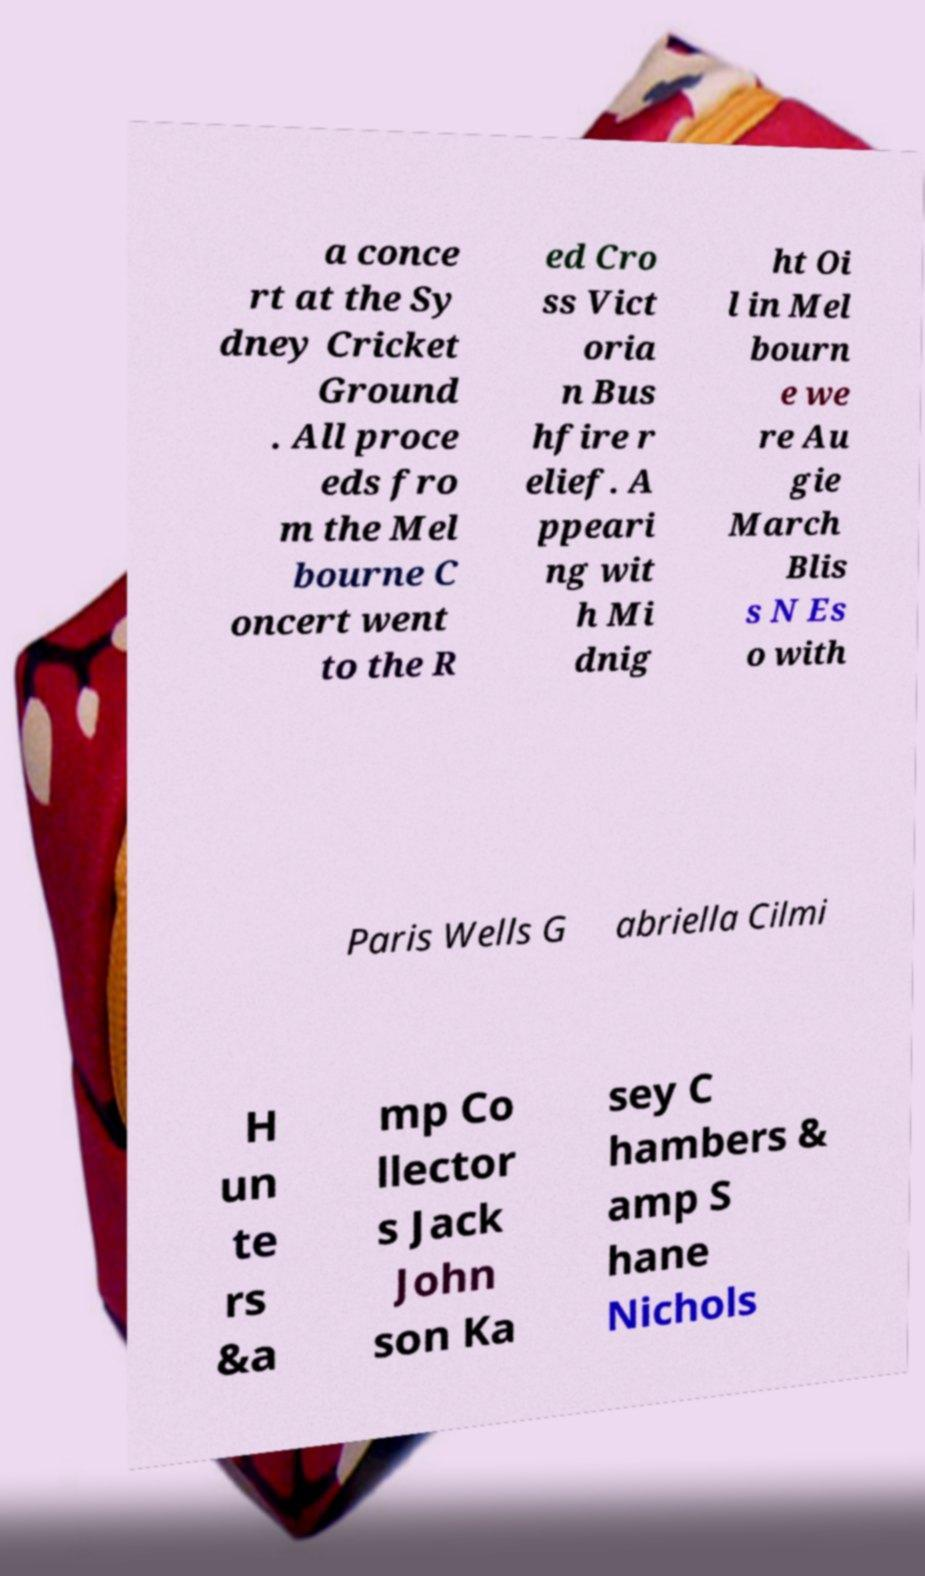Please identify and transcribe the text found in this image. a conce rt at the Sy dney Cricket Ground . All proce eds fro m the Mel bourne C oncert went to the R ed Cro ss Vict oria n Bus hfire r elief. A ppeari ng wit h Mi dnig ht Oi l in Mel bourn e we re Au gie March Blis s N Es o with Paris Wells G abriella Cilmi H un te rs &a mp Co llector s Jack John son Ka sey C hambers & amp S hane Nichols 